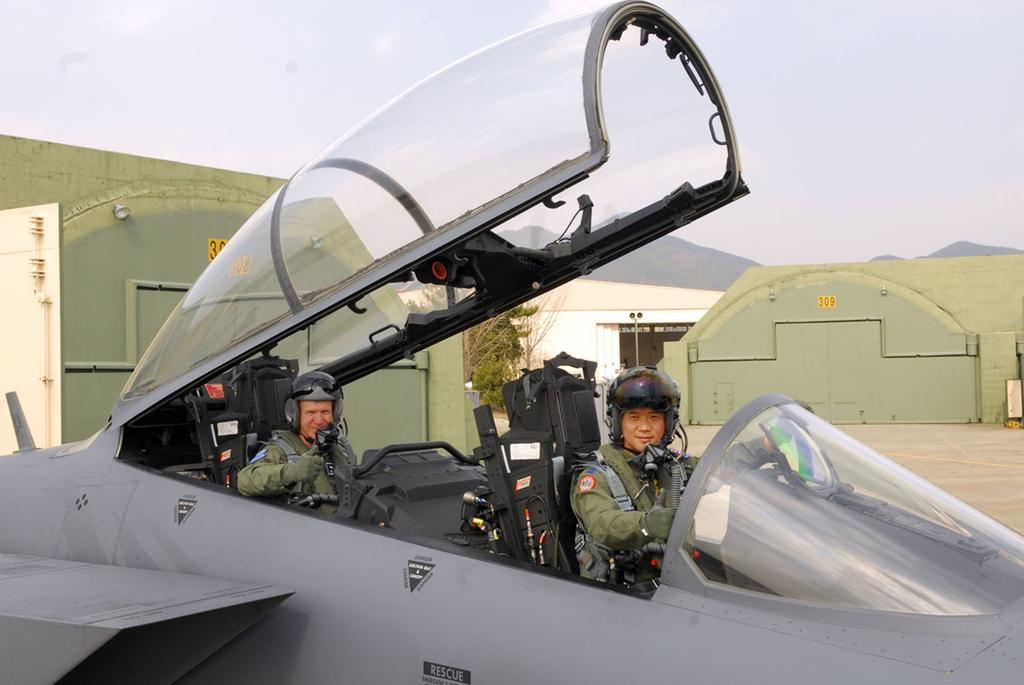<image>
Write a terse but informative summary of the picture. Pilots give the thumbs up to indicate they are ready to take off on a rescue mission. 